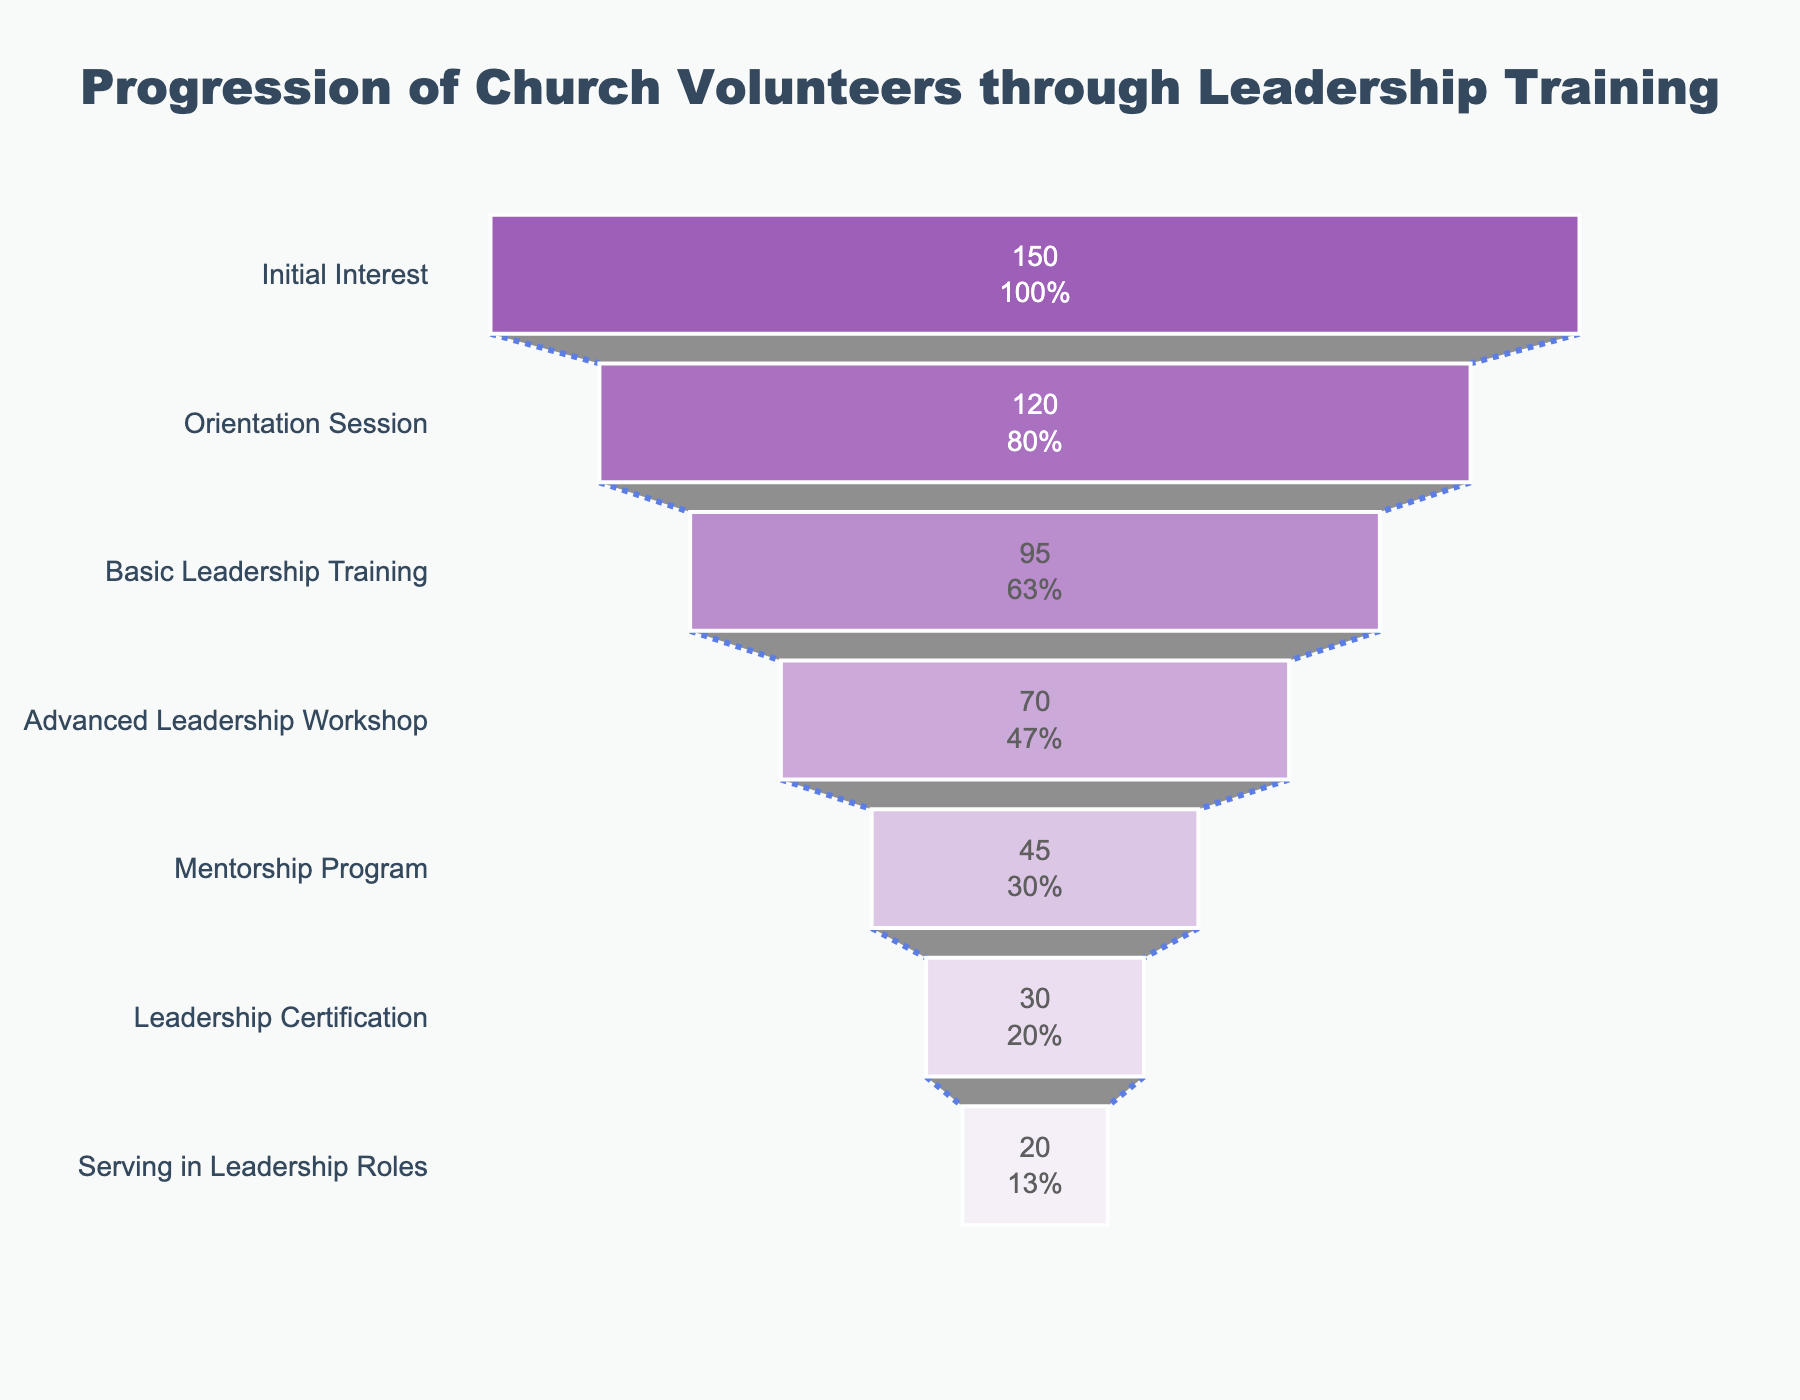What is the title of the funnel chart? The title of the funnel chart is located at the top and center of the chart. It reads: "Progression of Church Volunteers through Leadership Training".
Answer: Progression of Church Volunteers through Leadership Training What stage has the highest number of participants? The stage with the highest number of participants is the one at the top of the funnel and has the highest value. The stage is "Initial Interest" with 150 participants.
Answer: Initial Interest How many participants attend the Advanced Leadership Workshop? To find out how many participants attend the Advanced Leadership Workshop, look at the bar labeled "Advanced Leadership Workshop". It shows that there are 70 participants in this stage.
Answer: 70 What is the percentage drop from Initial Interest to Orientation Session? To find out the percentage drop, subtract the number of participants in the Orientation Session (120) from the number in Initial Interest (150). Next, divide by the number in Initial Interest and multiply by 100: (150 - 120) / 150 * 100. This equals 20%.
Answer: 20% How many participants complete both Basic Leadership Training and Advanced Leadership Workshop? Add the participants of both stages. Basic Leadership Training has 95 participants and Advanced Leadership Workshop has 70 participants. So: 95 + 70 = 165.
Answer: 165 Which stage sees the largest reduction in participants? Compare the reduction between each consecutive stage. The largest reduction is from the Basic Leadership Training (95) to the Advanced Leadership Workshop (70), a reduction of 25 participants.
Answer: Basic Leadership Training to Advanced Leadership Workshop What percentage of the initial participants end up serving in leadership roles? Start with the initial 150 participants and see how many end up serving in leadership roles, which is 20. The percentage is: (20 / 150) * 100 = 13.33%.
Answer: 13.33% How many more participants are in the Basic Leadership Training compared to the Mentorship Program? Calculate the difference between participants in these two stages: 95 (Basic Leadership Training) - 45 (Mentorship Program) = 50.
Answer: 50 What is the percentage drop from the Mentorship Program to Leadership Certification? Subtract the number of participants in Leadership Certification (30) from the number in Mentorship Program (45). Divide by the number in Mentorship Program and multiply by 100: (45 - 30) / 45 * 100 = 33.33%.
Answer: 33.33% How many participants are lost between the Orientation Session and Serving in Leadership Roles? Subtract the number of participants in Serving in Leadership Roles (20) from those in the Orientation Session (120). So, 120 - 20 = 100.
Answer: 100 